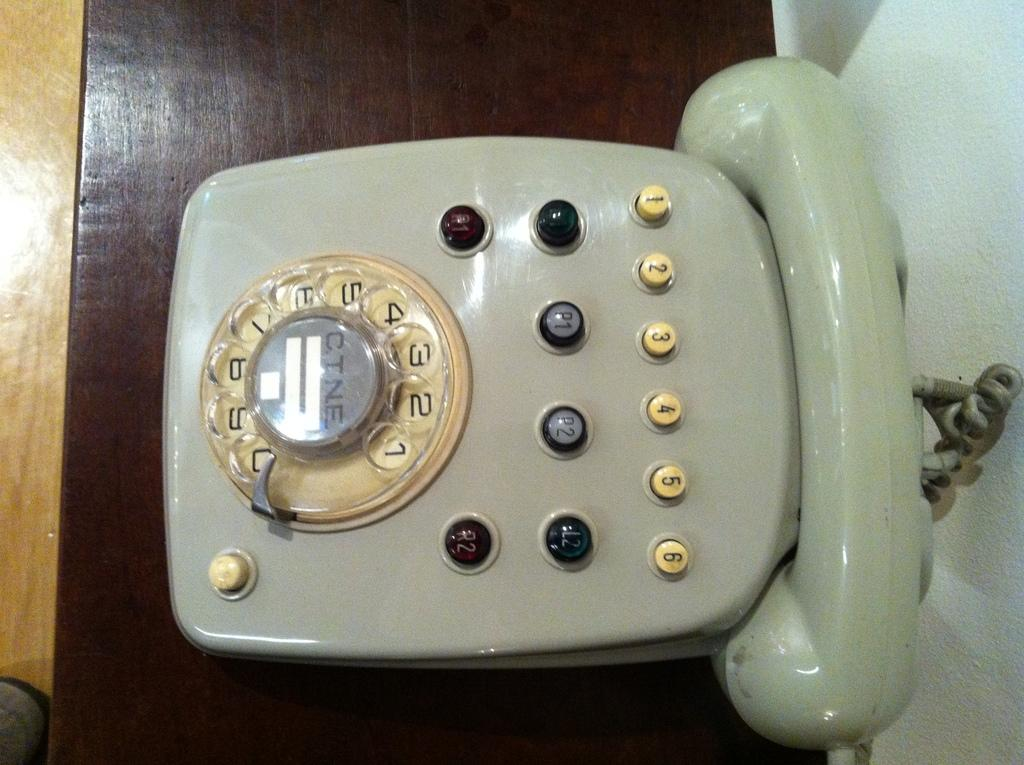What object can be seen in the image that is used for communication? There is a telephone in the image. Where is the telephone placed? The telephone is on a wooden table. What type of surface is visible beneath the table? There is a floor visible in the image. What is the background of the image made of? There is a wall in the image. What type of rock is being used as a paperweight on the telephone in the image? There is no rock or paperweight present on the telephone in the image. 